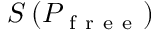Convert formula to latex. <formula><loc_0><loc_0><loc_500><loc_500>S \left ( P _ { f r e e } \right )</formula> 